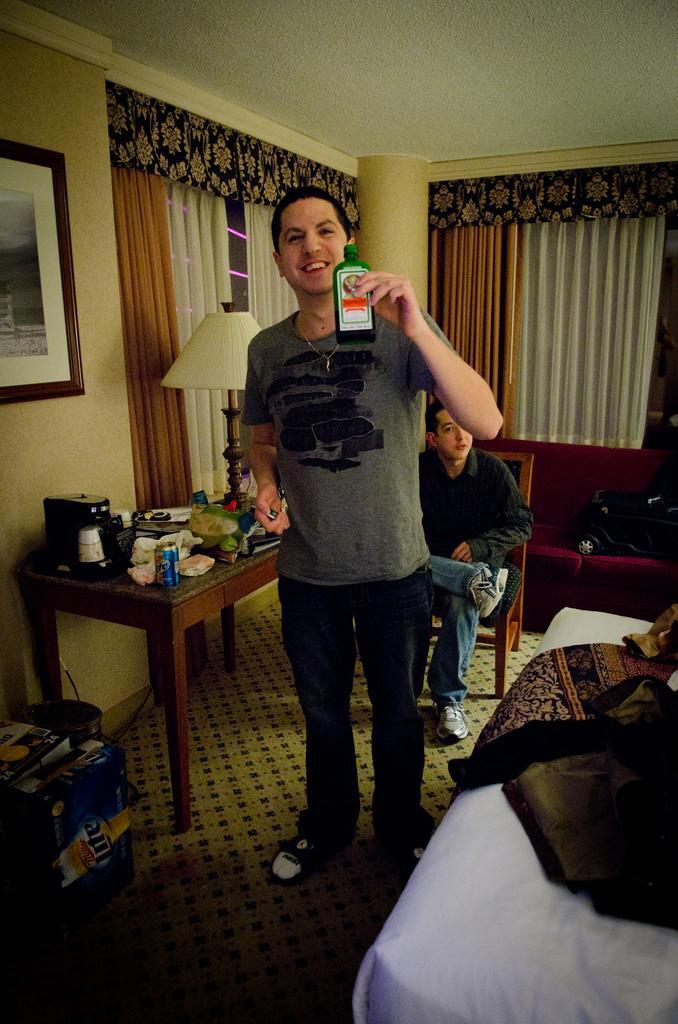Could you give a brief overview of what you see in this image? In the center we can see one man standing and he is smiling and he is holding bottle. On the right we can see bed and blanket. In the background there is a wall,photo frame,lamp,table,couch,backpack and one person sitting on the chair. 